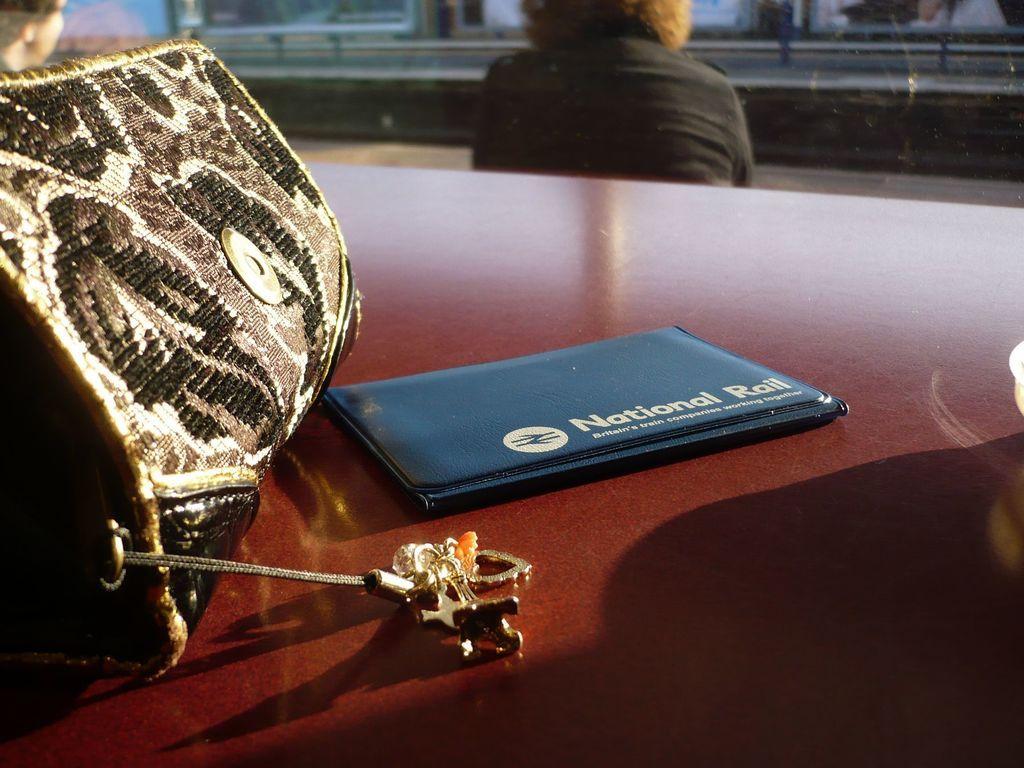Can you describe this image briefly? In this image there is a wooden table. There are purses on the table. In the center there is a purse. There is text on the purse. Behind the table there is a person sitting in the image. 